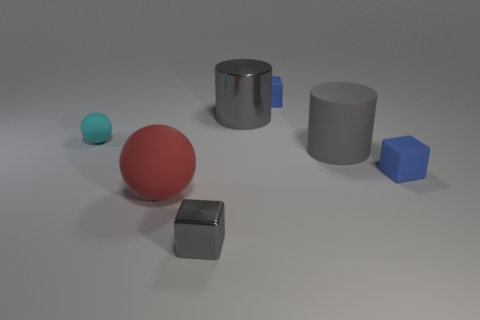There is another big cylinder that is the same color as the rubber cylinder; what is it made of?
Your answer should be compact. Metal. What shape is the big object that is the same color as the metallic cylinder?
Your response must be concise. Cylinder. What is the material of the small object that is in front of the small cyan rubber ball and right of the large metallic object?
Your answer should be compact. Rubber. Is there anything else that is the same shape as the big gray metal object?
Your response must be concise. Yes. What number of matte things are to the right of the cyan sphere and to the left of the tiny metal block?
Provide a short and direct response. 1. What is the big red object made of?
Ensure brevity in your answer.  Rubber. Are there an equal number of small matte blocks on the left side of the big red rubber sphere and large red spheres?
Your answer should be compact. No. What number of red objects are the same shape as the small cyan rubber object?
Your response must be concise. 1. Does the big red object have the same shape as the gray rubber object?
Provide a short and direct response. No. What number of things are blue things in front of the cyan object or tiny red rubber cylinders?
Offer a terse response. 1. 